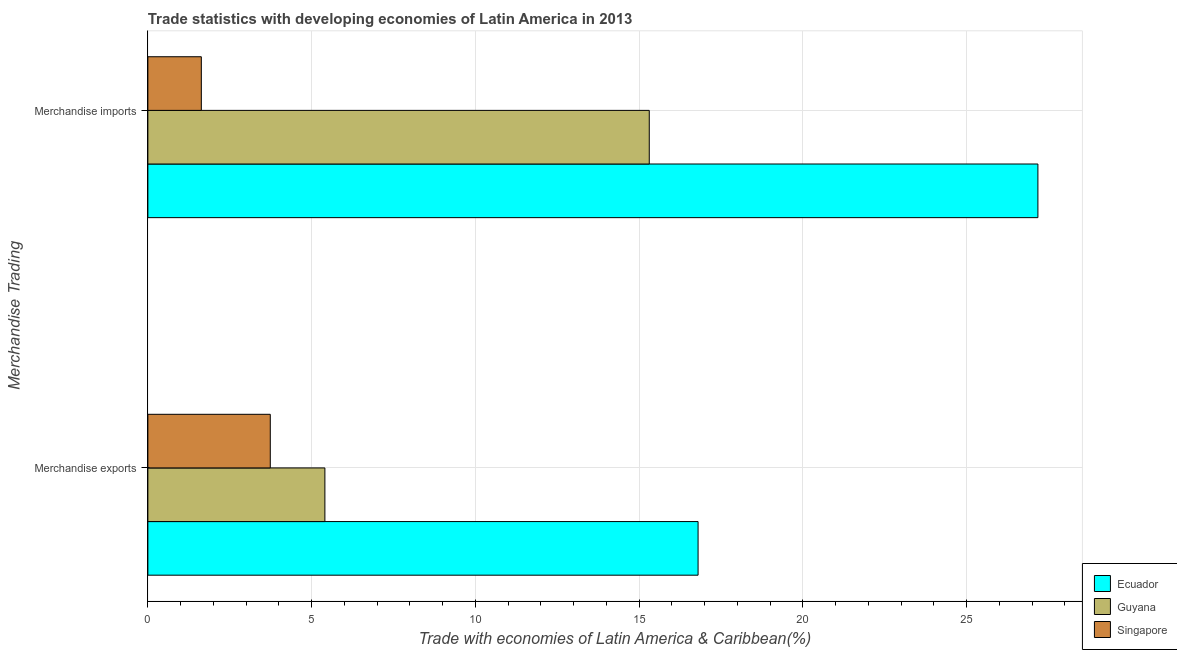How many bars are there on the 2nd tick from the top?
Make the answer very short. 3. How many bars are there on the 1st tick from the bottom?
Keep it short and to the point. 3. What is the label of the 2nd group of bars from the top?
Ensure brevity in your answer.  Merchandise exports. What is the merchandise exports in Singapore?
Your answer should be compact. 3.74. Across all countries, what is the maximum merchandise exports?
Provide a succinct answer. 16.8. Across all countries, what is the minimum merchandise exports?
Keep it short and to the point. 3.74. In which country was the merchandise exports maximum?
Your response must be concise. Ecuador. In which country was the merchandise exports minimum?
Give a very brief answer. Singapore. What is the total merchandise exports in the graph?
Provide a short and direct response. 25.94. What is the difference between the merchandise imports in Ecuador and that in Singapore?
Give a very brief answer. 25.54. What is the difference between the merchandise imports in Ecuador and the merchandise exports in Guyana?
Your answer should be compact. 21.77. What is the average merchandise imports per country?
Give a very brief answer. 14.71. What is the difference between the merchandise imports and merchandise exports in Ecuador?
Your answer should be compact. 10.38. In how many countries, is the merchandise imports greater than 14 %?
Provide a succinct answer. 2. What is the ratio of the merchandise exports in Singapore to that in Ecuador?
Make the answer very short. 0.22. Is the merchandise exports in Ecuador less than that in Guyana?
Give a very brief answer. No. What does the 1st bar from the top in Merchandise imports represents?
Offer a terse response. Singapore. What does the 2nd bar from the bottom in Merchandise exports represents?
Your response must be concise. Guyana. What is the difference between two consecutive major ticks on the X-axis?
Give a very brief answer. 5. Are the values on the major ticks of X-axis written in scientific E-notation?
Your answer should be compact. No. Where does the legend appear in the graph?
Provide a short and direct response. Bottom right. How are the legend labels stacked?
Give a very brief answer. Vertical. What is the title of the graph?
Your response must be concise. Trade statistics with developing economies of Latin America in 2013. Does "Slovenia" appear as one of the legend labels in the graph?
Your answer should be very brief. No. What is the label or title of the X-axis?
Your answer should be compact. Trade with economies of Latin America & Caribbean(%). What is the label or title of the Y-axis?
Your answer should be very brief. Merchandise Trading. What is the Trade with economies of Latin America & Caribbean(%) of Ecuador in Merchandise exports?
Your response must be concise. 16.8. What is the Trade with economies of Latin America & Caribbean(%) in Guyana in Merchandise exports?
Provide a succinct answer. 5.41. What is the Trade with economies of Latin America & Caribbean(%) in Singapore in Merchandise exports?
Your answer should be very brief. 3.74. What is the Trade with economies of Latin America & Caribbean(%) in Ecuador in Merchandise imports?
Offer a very short reply. 27.18. What is the Trade with economies of Latin America & Caribbean(%) in Guyana in Merchandise imports?
Your answer should be very brief. 15.31. What is the Trade with economies of Latin America & Caribbean(%) of Singapore in Merchandise imports?
Provide a succinct answer. 1.63. Across all Merchandise Trading, what is the maximum Trade with economies of Latin America & Caribbean(%) of Ecuador?
Your answer should be compact. 27.18. Across all Merchandise Trading, what is the maximum Trade with economies of Latin America & Caribbean(%) in Guyana?
Your answer should be very brief. 15.31. Across all Merchandise Trading, what is the maximum Trade with economies of Latin America & Caribbean(%) of Singapore?
Make the answer very short. 3.74. Across all Merchandise Trading, what is the minimum Trade with economies of Latin America & Caribbean(%) of Ecuador?
Ensure brevity in your answer.  16.8. Across all Merchandise Trading, what is the minimum Trade with economies of Latin America & Caribbean(%) of Guyana?
Give a very brief answer. 5.41. Across all Merchandise Trading, what is the minimum Trade with economies of Latin America & Caribbean(%) of Singapore?
Offer a terse response. 1.63. What is the total Trade with economies of Latin America & Caribbean(%) in Ecuador in the graph?
Provide a short and direct response. 43.98. What is the total Trade with economies of Latin America & Caribbean(%) of Guyana in the graph?
Your response must be concise. 20.71. What is the total Trade with economies of Latin America & Caribbean(%) of Singapore in the graph?
Offer a terse response. 5.37. What is the difference between the Trade with economies of Latin America & Caribbean(%) in Ecuador in Merchandise exports and that in Merchandise imports?
Provide a succinct answer. -10.38. What is the difference between the Trade with economies of Latin America & Caribbean(%) of Guyana in Merchandise exports and that in Merchandise imports?
Give a very brief answer. -9.9. What is the difference between the Trade with economies of Latin America & Caribbean(%) of Singapore in Merchandise exports and that in Merchandise imports?
Offer a very short reply. 2.11. What is the difference between the Trade with economies of Latin America & Caribbean(%) of Ecuador in Merchandise exports and the Trade with economies of Latin America & Caribbean(%) of Guyana in Merchandise imports?
Provide a short and direct response. 1.49. What is the difference between the Trade with economies of Latin America & Caribbean(%) of Ecuador in Merchandise exports and the Trade with economies of Latin America & Caribbean(%) of Singapore in Merchandise imports?
Your answer should be very brief. 15.17. What is the difference between the Trade with economies of Latin America & Caribbean(%) of Guyana in Merchandise exports and the Trade with economies of Latin America & Caribbean(%) of Singapore in Merchandise imports?
Provide a short and direct response. 3.77. What is the average Trade with economies of Latin America & Caribbean(%) of Ecuador per Merchandise Trading?
Keep it short and to the point. 21.99. What is the average Trade with economies of Latin America & Caribbean(%) of Guyana per Merchandise Trading?
Your answer should be compact. 10.36. What is the average Trade with economies of Latin America & Caribbean(%) in Singapore per Merchandise Trading?
Keep it short and to the point. 2.69. What is the difference between the Trade with economies of Latin America & Caribbean(%) in Ecuador and Trade with economies of Latin America & Caribbean(%) in Guyana in Merchandise exports?
Provide a succinct answer. 11.39. What is the difference between the Trade with economies of Latin America & Caribbean(%) in Ecuador and Trade with economies of Latin America & Caribbean(%) in Singapore in Merchandise exports?
Your answer should be compact. 13.06. What is the difference between the Trade with economies of Latin America & Caribbean(%) in Guyana and Trade with economies of Latin America & Caribbean(%) in Singapore in Merchandise exports?
Offer a very short reply. 1.67. What is the difference between the Trade with economies of Latin America & Caribbean(%) of Ecuador and Trade with economies of Latin America & Caribbean(%) of Guyana in Merchandise imports?
Provide a succinct answer. 11.87. What is the difference between the Trade with economies of Latin America & Caribbean(%) in Ecuador and Trade with economies of Latin America & Caribbean(%) in Singapore in Merchandise imports?
Your answer should be compact. 25.54. What is the difference between the Trade with economies of Latin America & Caribbean(%) of Guyana and Trade with economies of Latin America & Caribbean(%) of Singapore in Merchandise imports?
Your answer should be very brief. 13.68. What is the ratio of the Trade with economies of Latin America & Caribbean(%) in Ecuador in Merchandise exports to that in Merchandise imports?
Your answer should be very brief. 0.62. What is the ratio of the Trade with economies of Latin America & Caribbean(%) of Guyana in Merchandise exports to that in Merchandise imports?
Your answer should be very brief. 0.35. What is the ratio of the Trade with economies of Latin America & Caribbean(%) in Singapore in Merchandise exports to that in Merchandise imports?
Offer a terse response. 2.29. What is the difference between the highest and the second highest Trade with economies of Latin America & Caribbean(%) of Ecuador?
Offer a very short reply. 10.38. What is the difference between the highest and the second highest Trade with economies of Latin America & Caribbean(%) of Guyana?
Give a very brief answer. 9.9. What is the difference between the highest and the second highest Trade with economies of Latin America & Caribbean(%) in Singapore?
Ensure brevity in your answer.  2.11. What is the difference between the highest and the lowest Trade with economies of Latin America & Caribbean(%) in Ecuador?
Your response must be concise. 10.38. What is the difference between the highest and the lowest Trade with economies of Latin America & Caribbean(%) of Guyana?
Make the answer very short. 9.9. What is the difference between the highest and the lowest Trade with economies of Latin America & Caribbean(%) in Singapore?
Provide a succinct answer. 2.11. 